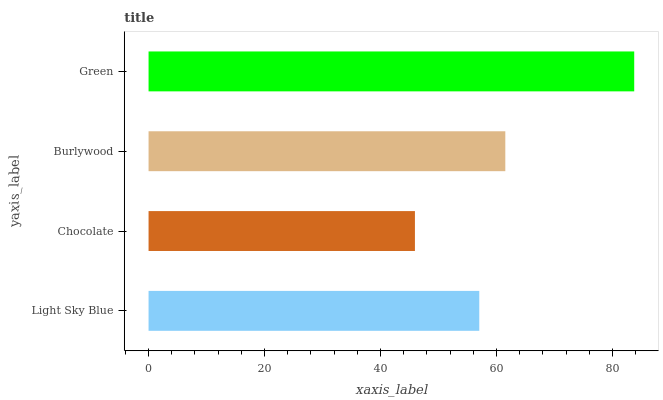Is Chocolate the minimum?
Answer yes or no. Yes. Is Green the maximum?
Answer yes or no. Yes. Is Burlywood the minimum?
Answer yes or no. No. Is Burlywood the maximum?
Answer yes or no. No. Is Burlywood greater than Chocolate?
Answer yes or no. Yes. Is Chocolate less than Burlywood?
Answer yes or no. Yes. Is Chocolate greater than Burlywood?
Answer yes or no. No. Is Burlywood less than Chocolate?
Answer yes or no. No. Is Burlywood the high median?
Answer yes or no. Yes. Is Light Sky Blue the low median?
Answer yes or no. Yes. Is Chocolate the high median?
Answer yes or no. No. Is Burlywood the low median?
Answer yes or no. No. 